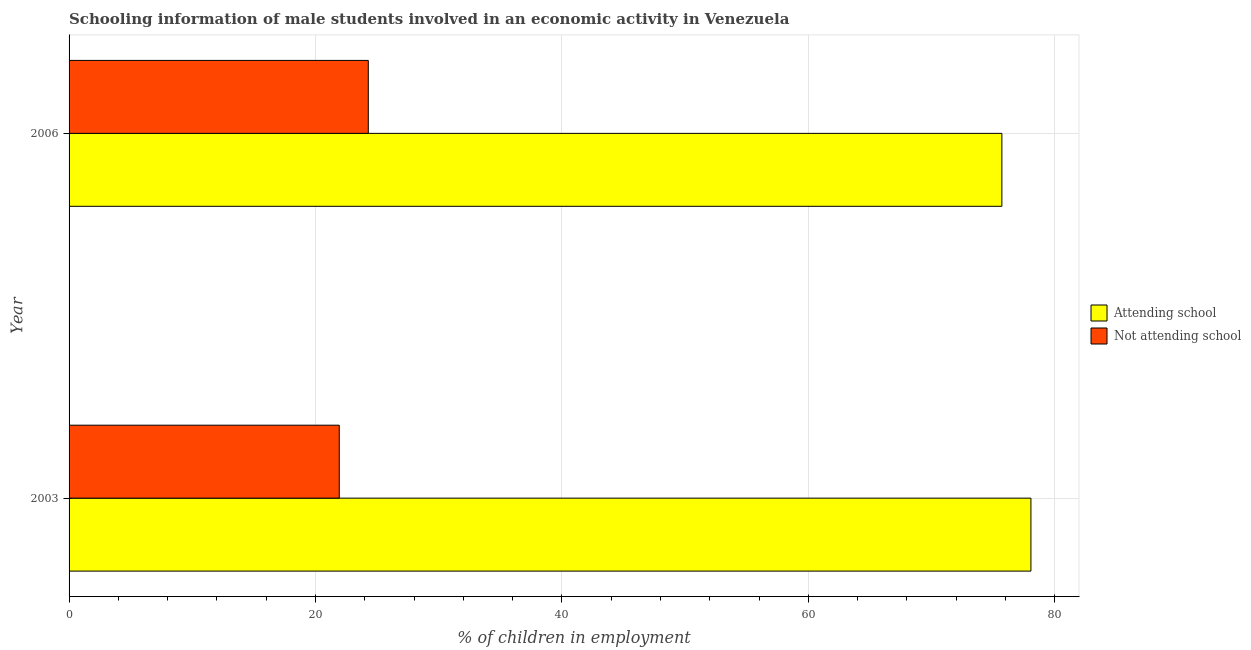How many groups of bars are there?
Your answer should be compact. 2. Are the number of bars per tick equal to the number of legend labels?
Make the answer very short. Yes. How many bars are there on the 2nd tick from the top?
Your answer should be compact. 2. How many bars are there on the 1st tick from the bottom?
Ensure brevity in your answer.  2. What is the label of the 2nd group of bars from the top?
Offer a very short reply. 2003. In how many cases, is the number of bars for a given year not equal to the number of legend labels?
Offer a terse response. 0. What is the percentage of employed males who are attending school in 2006?
Make the answer very short. 75.71. Across all years, what is the maximum percentage of employed males who are not attending school?
Your response must be concise. 24.29. Across all years, what is the minimum percentage of employed males who are attending school?
Your answer should be compact. 75.71. In which year was the percentage of employed males who are not attending school maximum?
Make the answer very short. 2006. In which year was the percentage of employed males who are attending school minimum?
Your answer should be compact. 2006. What is the total percentage of employed males who are attending school in the graph?
Your answer should be very brief. 153.78. What is the difference between the percentage of employed males who are attending school in 2003 and that in 2006?
Ensure brevity in your answer.  2.36. What is the difference between the percentage of employed males who are not attending school in 2003 and the percentage of employed males who are attending school in 2006?
Make the answer very short. -53.78. What is the average percentage of employed males who are not attending school per year?
Your response must be concise. 23.11. In the year 2006, what is the difference between the percentage of employed males who are not attending school and percentage of employed males who are attending school?
Make the answer very short. -51.43. What is the ratio of the percentage of employed males who are not attending school in 2003 to that in 2006?
Give a very brief answer. 0.9. In how many years, is the percentage of employed males who are attending school greater than the average percentage of employed males who are attending school taken over all years?
Make the answer very short. 1. What does the 1st bar from the top in 2006 represents?
Provide a succinct answer. Not attending school. What does the 1st bar from the bottom in 2003 represents?
Ensure brevity in your answer.  Attending school. Does the graph contain grids?
Offer a very short reply. Yes. Where does the legend appear in the graph?
Offer a very short reply. Center right. How are the legend labels stacked?
Keep it short and to the point. Vertical. What is the title of the graph?
Ensure brevity in your answer.  Schooling information of male students involved in an economic activity in Venezuela. Does "Mobile cellular" appear as one of the legend labels in the graph?
Give a very brief answer. No. What is the label or title of the X-axis?
Your answer should be compact. % of children in employment. What is the label or title of the Y-axis?
Provide a succinct answer. Year. What is the % of children in employment in Attending school in 2003?
Your response must be concise. 78.07. What is the % of children in employment in Not attending school in 2003?
Ensure brevity in your answer.  21.93. What is the % of children in employment of Attending school in 2006?
Your answer should be compact. 75.71. What is the % of children in employment of Not attending school in 2006?
Provide a short and direct response. 24.29. Across all years, what is the maximum % of children in employment in Attending school?
Provide a short and direct response. 78.07. Across all years, what is the maximum % of children in employment in Not attending school?
Make the answer very short. 24.29. Across all years, what is the minimum % of children in employment of Attending school?
Your response must be concise. 75.71. Across all years, what is the minimum % of children in employment of Not attending school?
Offer a terse response. 21.93. What is the total % of children in employment in Attending school in the graph?
Your answer should be compact. 153.78. What is the total % of children in employment in Not attending school in the graph?
Your answer should be compact. 46.22. What is the difference between the % of children in employment in Attending school in 2003 and that in 2006?
Keep it short and to the point. 2.36. What is the difference between the % of children in employment in Not attending school in 2003 and that in 2006?
Your answer should be compact. -2.36. What is the difference between the % of children in employment of Attending school in 2003 and the % of children in employment of Not attending school in 2006?
Your answer should be compact. 53.78. What is the average % of children in employment of Attending school per year?
Provide a succinct answer. 76.89. What is the average % of children in employment in Not attending school per year?
Provide a short and direct response. 23.11. In the year 2003, what is the difference between the % of children in employment of Attending school and % of children in employment of Not attending school?
Your answer should be compact. 56.14. In the year 2006, what is the difference between the % of children in employment in Attending school and % of children in employment in Not attending school?
Your response must be concise. 51.43. What is the ratio of the % of children in employment of Attending school in 2003 to that in 2006?
Offer a very short reply. 1.03. What is the ratio of the % of children in employment in Not attending school in 2003 to that in 2006?
Keep it short and to the point. 0.9. What is the difference between the highest and the second highest % of children in employment in Attending school?
Give a very brief answer. 2.36. What is the difference between the highest and the second highest % of children in employment of Not attending school?
Offer a terse response. 2.36. What is the difference between the highest and the lowest % of children in employment of Attending school?
Keep it short and to the point. 2.36. What is the difference between the highest and the lowest % of children in employment of Not attending school?
Give a very brief answer. 2.36. 